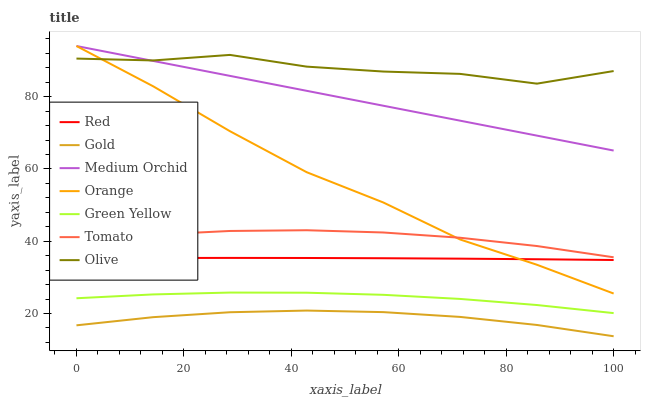Does Gold have the minimum area under the curve?
Answer yes or no. Yes. Does Olive have the maximum area under the curve?
Answer yes or no. Yes. Does Medium Orchid have the minimum area under the curve?
Answer yes or no. No. Does Medium Orchid have the maximum area under the curve?
Answer yes or no. No. Is Medium Orchid the smoothest?
Answer yes or no. Yes. Is Olive the roughest?
Answer yes or no. Yes. Is Gold the smoothest?
Answer yes or no. No. Is Gold the roughest?
Answer yes or no. No. Does Gold have the lowest value?
Answer yes or no. Yes. Does Medium Orchid have the lowest value?
Answer yes or no. No. Does Orange have the highest value?
Answer yes or no. Yes. Does Gold have the highest value?
Answer yes or no. No. Is Red less than Olive?
Answer yes or no. Yes. Is Olive greater than Green Yellow?
Answer yes or no. Yes. Does Orange intersect Olive?
Answer yes or no. Yes. Is Orange less than Olive?
Answer yes or no. No. Is Orange greater than Olive?
Answer yes or no. No. Does Red intersect Olive?
Answer yes or no. No. 